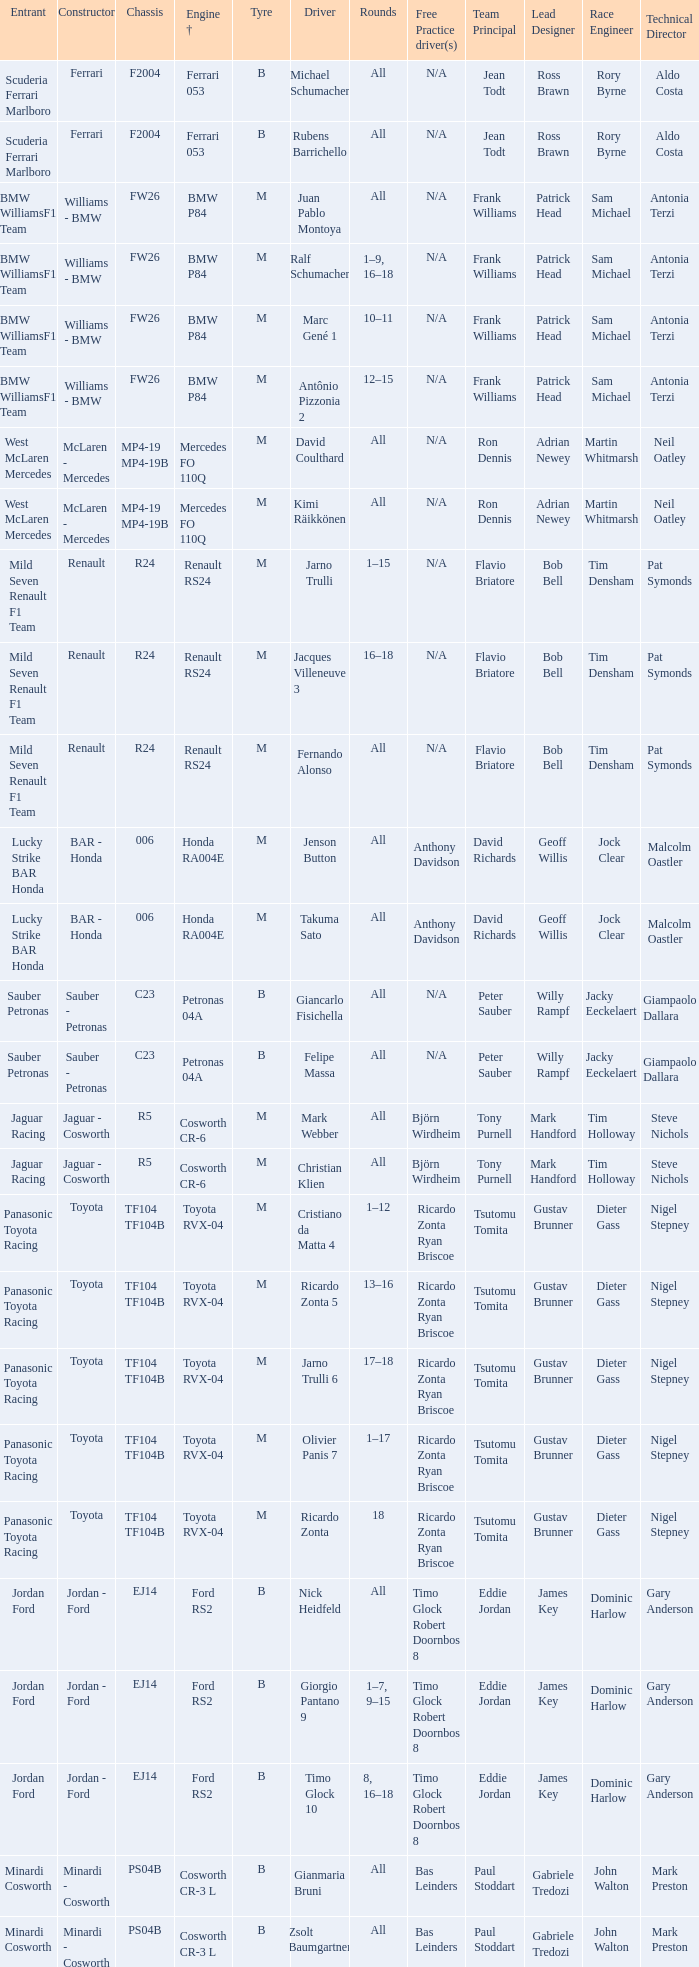What kind of free practice is there with a Ford RS2 engine +? Timo Glock Robert Doornbos 8, Timo Glock Robert Doornbos 8, Timo Glock Robert Doornbos 8. 